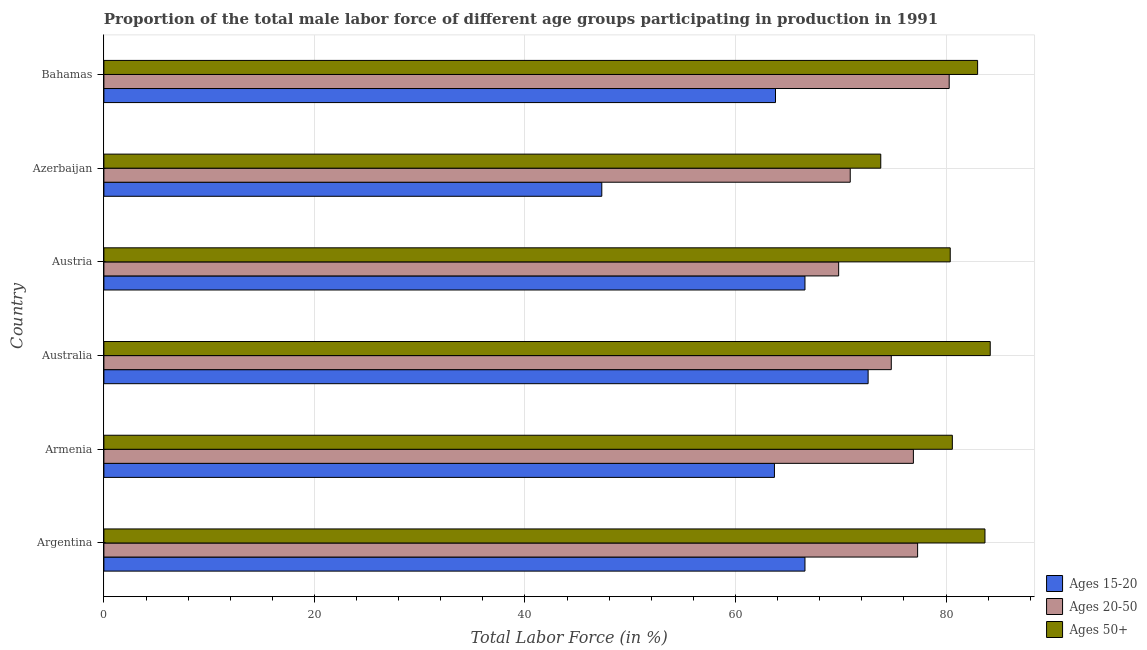Are the number of bars on each tick of the Y-axis equal?
Keep it short and to the point. Yes. What is the label of the 5th group of bars from the top?
Your answer should be very brief. Armenia. In how many cases, is the number of bars for a given country not equal to the number of legend labels?
Offer a very short reply. 0. What is the percentage of male labor force within the age group 20-50 in Armenia?
Ensure brevity in your answer.  76.9. Across all countries, what is the maximum percentage of male labor force within the age group 15-20?
Your answer should be very brief. 72.6. Across all countries, what is the minimum percentage of male labor force above age 50?
Make the answer very short. 73.8. In which country was the percentage of male labor force within the age group 15-20 minimum?
Your answer should be very brief. Azerbaijan. What is the total percentage of male labor force within the age group 20-50 in the graph?
Give a very brief answer. 450. What is the difference between the percentage of male labor force within the age group 15-20 in Austria and the percentage of male labor force above age 50 in Azerbaijan?
Offer a very short reply. -7.2. What is the average percentage of male labor force above age 50 per country?
Your answer should be compact. 80.95. What is the difference between the percentage of male labor force within the age group 15-20 and percentage of male labor force above age 50 in Argentina?
Ensure brevity in your answer.  -17.1. What is the ratio of the percentage of male labor force above age 50 in Australia to that in Austria?
Ensure brevity in your answer.  1.05. Is the difference between the percentage of male labor force above age 50 in Austria and Bahamas greater than the difference between the percentage of male labor force within the age group 15-20 in Austria and Bahamas?
Your response must be concise. No. What is the difference between the highest and the second highest percentage of male labor force above age 50?
Offer a very short reply. 0.5. What is the difference between the highest and the lowest percentage of male labor force within the age group 15-20?
Offer a very short reply. 25.3. Is the sum of the percentage of male labor force within the age group 15-20 in Austria and Azerbaijan greater than the maximum percentage of male labor force within the age group 20-50 across all countries?
Provide a succinct answer. Yes. What does the 3rd bar from the top in Azerbaijan represents?
Offer a very short reply. Ages 15-20. What does the 2nd bar from the bottom in Austria represents?
Offer a very short reply. Ages 20-50. Is it the case that in every country, the sum of the percentage of male labor force within the age group 15-20 and percentage of male labor force within the age group 20-50 is greater than the percentage of male labor force above age 50?
Make the answer very short. Yes. Are all the bars in the graph horizontal?
Your answer should be compact. Yes. Are the values on the major ticks of X-axis written in scientific E-notation?
Give a very brief answer. No. What is the title of the graph?
Provide a short and direct response. Proportion of the total male labor force of different age groups participating in production in 1991. What is the label or title of the X-axis?
Offer a very short reply. Total Labor Force (in %). What is the Total Labor Force (in %) in Ages 15-20 in Argentina?
Your response must be concise. 66.6. What is the Total Labor Force (in %) in Ages 20-50 in Argentina?
Your answer should be compact. 77.3. What is the Total Labor Force (in %) in Ages 50+ in Argentina?
Keep it short and to the point. 83.7. What is the Total Labor Force (in %) in Ages 15-20 in Armenia?
Give a very brief answer. 63.7. What is the Total Labor Force (in %) of Ages 20-50 in Armenia?
Offer a terse response. 76.9. What is the Total Labor Force (in %) of Ages 50+ in Armenia?
Provide a short and direct response. 80.6. What is the Total Labor Force (in %) in Ages 15-20 in Australia?
Ensure brevity in your answer.  72.6. What is the Total Labor Force (in %) of Ages 20-50 in Australia?
Offer a very short reply. 74.8. What is the Total Labor Force (in %) in Ages 50+ in Australia?
Give a very brief answer. 84.2. What is the Total Labor Force (in %) of Ages 15-20 in Austria?
Your answer should be compact. 66.6. What is the Total Labor Force (in %) of Ages 20-50 in Austria?
Your answer should be very brief. 69.8. What is the Total Labor Force (in %) in Ages 50+ in Austria?
Make the answer very short. 80.4. What is the Total Labor Force (in %) of Ages 15-20 in Azerbaijan?
Keep it short and to the point. 47.3. What is the Total Labor Force (in %) in Ages 20-50 in Azerbaijan?
Your response must be concise. 70.9. What is the Total Labor Force (in %) in Ages 50+ in Azerbaijan?
Give a very brief answer. 73.8. What is the Total Labor Force (in %) in Ages 15-20 in Bahamas?
Keep it short and to the point. 63.8. What is the Total Labor Force (in %) of Ages 20-50 in Bahamas?
Your response must be concise. 80.3. What is the Total Labor Force (in %) in Ages 50+ in Bahamas?
Make the answer very short. 83. Across all countries, what is the maximum Total Labor Force (in %) of Ages 15-20?
Your answer should be compact. 72.6. Across all countries, what is the maximum Total Labor Force (in %) of Ages 20-50?
Offer a terse response. 80.3. Across all countries, what is the maximum Total Labor Force (in %) of Ages 50+?
Offer a very short reply. 84.2. Across all countries, what is the minimum Total Labor Force (in %) in Ages 15-20?
Keep it short and to the point. 47.3. Across all countries, what is the minimum Total Labor Force (in %) of Ages 20-50?
Offer a terse response. 69.8. Across all countries, what is the minimum Total Labor Force (in %) in Ages 50+?
Offer a very short reply. 73.8. What is the total Total Labor Force (in %) of Ages 15-20 in the graph?
Your response must be concise. 380.6. What is the total Total Labor Force (in %) of Ages 20-50 in the graph?
Offer a very short reply. 450. What is the total Total Labor Force (in %) in Ages 50+ in the graph?
Make the answer very short. 485.7. What is the difference between the Total Labor Force (in %) in Ages 15-20 in Argentina and that in Armenia?
Keep it short and to the point. 2.9. What is the difference between the Total Labor Force (in %) in Ages 50+ in Argentina and that in Armenia?
Give a very brief answer. 3.1. What is the difference between the Total Labor Force (in %) of Ages 15-20 in Argentina and that in Australia?
Keep it short and to the point. -6. What is the difference between the Total Labor Force (in %) in Ages 20-50 in Argentina and that in Australia?
Ensure brevity in your answer.  2.5. What is the difference between the Total Labor Force (in %) of Ages 20-50 in Argentina and that in Austria?
Provide a short and direct response. 7.5. What is the difference between the Total Labor Force (in %) in Ages 50+ in Argentina and that in Austria?
Your answer should be very brief. 3.3. What is the difference between the Total Labor Force (in %) in Ages 15-20 in Argentina and that in Azerbaijan?
Ensure brevity in your answer.  19.3. What is the difference between the Total Labor Force (in %) in Ages 20-50 in Argentina and that in Azerbaijan?
Ensure brevity in your answer.  6.4. What is the difference between the Total Labor Force (in %) in Ages 50+ in Argentina and that in Azerbaijan?
Keep it short and to the point. 9.9. What is the difference between the Total Labor Force (in %) of Ages 15-20 in Argentina and that in Bahamas?
Offer a terse response. 2.8. What is the difference between the Total Labor Force (in %) in Ages 20-50 in Armenia and that in Austria?
Make the answer very short. 7.1. What is the difference between the Total Labor Force (in %) in Ages 50+ in Armenia and that in Austria?
Provide a short and direct response. 0.2. What is the difference between the Total Labor Force (in %) in Ages 15-20 in Armenia and that in Azerbaijan?
Offer a very short reply. 16.4. What is the difference between the Total Labor Force (in %) in Ages 20-50 in Armenia and that in Azerbaijan?
Your response must be concise. 6. What is the difference between the Total Labor Force (in %) of Ages 15-20 in Armenia and that in Bahamas?
Ensure brevity in your answer.  -0.1. What is the difference between the Total Labor Force (in %) of Ages 20-50 in Armenia and that in Bahamas?
Ensure brevity in your answer.  -3.4. What is the difference between the Total Labor Force (in %) of Ages 50+ in Australia and that in Austria?
Ensure brevity in your answer.  3.8. What is the difference between the Total Labor Force (in %) of Ages 15-20 in Australia and that in Azerbaijan?
Your answer should be compact. 25.3. What is the difference between the Total Labor Force (in %) in Ages 50+ in Australia and that in Azerbaijan?
Keep it short and to the point. 10.4. What is the difference between the Total Labor Force (in %) of Ages 50+ in Australia and that in Bahamas?
Provide a short and direct response. 1.2. What is the difference between the Total Labor Force (in %) of Ages 15-20 in Austria and that in Azerbaijan?
Provide a succinct answer. 19.3. What is the difference between the Total Labor Force (in %) of Ages 20-50 in Austria and that in Azerbaijan?
Your response must be concise. -1.1. What is the difference between the Total Labor Force (in %) of Ages 50+ in Austria and that in Azerbaijan?
Keep it short and to the point. 6.6. What is the difference between the Total Labor Force (in %) of Ages 20-50 in Austria and that in Bahamas?
Offer a terse response. -10.5. What is the difference between the Total Labor Force (in %) of Ages 50+ in Austria and that in Bahamas?
Offer a very short reply. -2.6. What is the difference between the Total Labor Force (in %) of Ages 15-20 in Azerbaijan and that in Bahamas?
Give a very brief answer. -16.5. What is the difference between the Total Labor Force (in %) in Ages 20-50 in Azerbaijan and that in Bahamas?
Ensure brevity in your answer.  -9.4. What is the difference between the Total Labor Force (in %) in Ages 15-20 in Argentina and the Total Labor Force (in %) in Ages 50+ in Armenia?
Your answer should be compact. -14. What is the difference between the Total Labor Force (in %) of Ages 15-20 in Argentina and the Total Labor Force (in %) of Ages 20-50 in Australia?
Your response must be concise. -8.2. What is the difference between the Total Labor Force (in %) in Ages 15-20 in Argentina and the Total Labor Force (in %) in Ages 50+ in Australia?
Offer a very short reply. -17.6. What is the difference between the Total Labor Force (in %) in Ages 15-20 in Argentina and the Total Labor Force (in %) in Ages 20-50 in Austria?
Give a very brief answer. -3.2. What is the difference between the Total Labor Force (in %) in Ages 15-20 in Argentina and the Total Labor Force (in %) in Ages 50+ in Austria?
Your answer should be very brief. -13.8. What is the difference between the Total Labor Force (in %) of Ages 15-20 in Argentina and the Total Labor Force (in %) of Ages 20-50 in Azerbaijan?
Ensure brevity in your answer.  -4.3. What is the difference between the Total Labor Force (in %) of Ages 15-20 in Argentina and the Total Labor Force (in %) of Ages 50+ in Azerbaijan?
Offer a very short reply. -7.2. What is the difference between the Total Labor Force (in %) of Ages 15-20 in Argentina and the Total Labor Force (in %) of Ages 20-50 in Bahamas?
Offer a terse response. -13.7. What is the difference between the Total Labor Force (in %) of Ages 15-20 in Argentina and the Total Labor Force (in %) of Ages 50+ in Bahamas?
Your answer should be compact. -16.4. What is the difference between the Total Labor Force (in %) of Ages 20-50 in Argentina and the Total Labor Force (in %) of Ages 50+ in Bahamas?
Give a very brief answer. -5.7. What is the difference between the Total Labor Force (in %) in Ages 15-20 in Armenia and the Total Labor Force (in %) in Ages 50+ in Australia?
Ensure brevity in your answer.  -20.5. What is the difference between the Total Labor Force (in %) in Ages 20-50 in Armenia and the Total Labor Force (in %) in Ages 50+ in Australia?
Keep it short and to the point. -7.3. What is the difference between the Total Labor Force (in %) of Ages 15-20 in Armenia and the Total Labor Force (in %) of Ages 50+ in Austria?
Your response must be concise. -16.7. What is the difference between the Total Labor Force (in %) of Ages 20-50 in Armenia and the Total Labor Force (in %) of Ages 50+ in Austria?
Ensure brevity in your answer.  -3.5. What is the difference between the Total Labor Force (in %) of Ages 20-50 in Armenia and the Total Labor Force (in %) of Ages 50+ in Azerbaijan?
Your answer should be compact. 3.1. What is the difference between the Total Labor Force (in %) of Ages 15-20 in Armenia and the Total Labor Force (in %) of Ages 20-50 in Bahamas?
Provide a short and direct response. -16.6. What is the difference between the Total Labor Force (in %) of Ages 15-20 in Armenia and the Total Labor Force (in %) of Ages 50+ in Bahamas?
Your response must be concise. -19.3. What is the difference between the Total Labor Force (in %) in Ages 15-20 in Australia and the Total Labor Force (in %) in Ages 20-50 in Austria?
Your response must be concise. 2.8. What is the difference between the Total Labor Force (in %) of Ages 15-20 in Australia and the Total Labor Force (in %) of Ages 50+ in Austria?
Your response must be concise. -7.8. What is the difference between the Total Labor Force (in %) in Ages 20-50 in Australia and the Total Labor Force (in %) in Ages 50+ in Austria?
Provide a short and direct response. -5.6. What is the difference between the Total Labor Force (in %) of Ages 20-50 in Australia and the Total Labor Force (in %) of Ages 50+ in Azerbaijan?
Provide a succinct answer. 1. What is the difference between the Total Labor Force (in %) in Ages 15-20 in Australia and the Total Labor Force (in %) in Ages 50+ in Bahamas?
Your response must be concise. -10.4. What is the difference between the Total Labor Force (in %) in Ages 20-50 in Australia and the Total Labor Force (in %) in Ages 50+ in Bahamas?
Offer a very short reply. -8.2. What is the difference between the Total Labor Force (in %) of Ages 15-20 in Austria and the Total Labor Force (in %) of Ages 50+ in Azerbaijan?
Give a very brief answer. -7.2. What is the difference between the Total Labor Force (in %) of Ages 15-20 in Austria and the Total Labor Force (in %) of Ages 20-50 in Bahamas?
Keep it short and to the point. -13.7. What is the difference between the Total Labor Force (in %) in Ages 15-20 in Austria and the Total Labor Force (in %) in Ages 50+ in Bahamas?
Your answer should be compact. -16.4. What is the difference between the Total Labor Force (in %) in Ages 20-50 in Austria and the Total Labor Force (in %) in Ages 50+ in Bahamas?
Make the answer very short. -13.2. What is the difference between the Total Labor Force (in %) in Ages 15-20 in Azerbaijan and the Total Labor Force (in %) in Ages 20-50 in Bahamas?
Make the answer very short. -33. What is the difference between the Total Labor Force (in %) of Ages 15-20 in Azerbaijan and the Total Labor Force (in %) of Ages 50+ in Bahamas?
Keep it short and to the point. -35.7. What is the average Total Labor Force (in %) in Ages 15-20 per country?
Make the answer very short. 63.43. What is the average Total Labor Force (in %) in Ages 20-50 per country?
Keep it short and to the point. 75. What is the average Total Labor Force (in %) in Ages 50+ per country?
Offer a very short reply. 80.95. What is the difference between the Total Labor Force (in %) in Ages 15-20 and Total Labor Force (in %) in Ages 20-50 in Argentina?
Make the answer very short. -10.7. What is the difference between the Total Labor Force (in %) of Ages 15-20 and Total Labor Force (in %) of Ages 50+ in Argentina?
Give a very brief answer. -17.1. What is the difference between the Total Labor Force (in %) of Ages 15-20 and Total Labor Force (in %) of Ages 50+ in Armenia?
Give a very brief answer. -16.9. What is the difference between the Total Labor Force (in %) in Ages 20-50 and Total Labor Force (in %) in Ages 50+ in Armenia?
Offer a very short reply. -3.7. What is the difference between the Total Labor Force (in %) in Ages 15-20 and Total Labor Force (in %) in Ages 20-50 in Australia?
Offer a very short reply. -2.2. What is the difference between the Total Labor Force (in %) in Ages 15-20 and Total Labor Force (in %) in Ages 50+ in Australia?
Offer a very short reply. -11.6. What is the difference between the Total Labor Force (in %) of Ages 20-50 and Total Labor Force (in %) of Ages 50+ in Australia?
Your response must be concise. -9.4. What is the difference between the Total Labor Force (in %) of Ages 15-20 and Total Labor Force (in %) of Ages 50+ in Austria?
Offer a very short reply. -13.8. What is the difference between the Total Labor Force (in %) of Ages 15-20 and Total Labor Force (in %) of Ages 20-50 in Azerbaijan?
Offer a very short reply. -23.6. What is the difference between the Total Labor Force (in %) of Ages 15-20 and Total Labor Force (in %) of Ages 50+ in Azerbaijan?
Make the answer very short. -26.5. What is the difference between the Total Labor Force (in %) of Ages 15-20 and Total Labor Force (in %) of Ages 20-50 in Bahamas?
Offer a terse response. -16.5. What is the difference between the Total Labor Force (in %) of Ages 15-20 and Total Labor Force (in %) of Ages 50+ in Bahamas?
Your response must be concise. -19.2. What is the difference between the Total Labor Force (in %) of Ages 20-50 and Total Labor Force (in %) of Ages 50+ in Bahamas?
Your response must be concise. -2.7. What is the ratio of the Total Labor Force (in %) in Ages 15-20 in Argentina to that in Armenia?
Your answer should be very brief. 1.05. What is the ratio of the Total Labor Force (in %) in Ages 20-50 in Argentina to that in Armenia?
Offer a very short reply. 1.01. What is the ratio of the Total Labor Force (in %) in Ages 15-20 in Argentina to that in Australia?
Make the answer very short. 0.92. What is the ratio of the Total Labor Force (in %) of Ages 20-50 in Argentina to that in Australia?
Your answer should be compact. 1.03. What is the ratio of the Total Labor Force (in %) of Ages 15-20 in Argentina to that in Austria?
Offer a terse response. 1. What is the ratio of the Total Labor Force (in %) of Ages 20-50 in Argentina to that in Austria?
Your answer should be very brief. 1.11. What is the ratio of the Total Labor Force (in %) of Ages 50+ in Argentina to that in Austria?
Ensure brevity in your answer.  1.04. What is the ratio of the Total Labor Force (in %) of Ages 15-20 in Argentina to that in Azerbaijan?
Offer a very short reply. 1.41. What is the ratio of the Total Labor Force (in %) of Ages 20-50 in Argentina to that in Azerbaijan?
Ensure brevity in your answer.  1.09. What is the ratio of the Total Labor Force (in %) in Ages 50+ in Argentina to that in Azerbaijan?
Provide a succinct answer. 1.13. What is the ratio of the Total Labor Force (in %) of Ages 15-20 in Argentina to that in Bahamas?
Your answer should be very brief. 1.04. What is the ratio of the Total Labor Force (in %) in Ages 20-50 in Argentina to that in Bahamas?
Offer a terse response. 0.96. What is the ratio of the Total Labor Force (in %) in Ages 50+ in Argentina to that in Bahamas?
Make the answer very short. 1.01. What is the ratio of the Total Labor Force (in %) of Ages 15-20 in Armenia to that in Australia?
Make the answer very short. 0.88. What is the ratio of the Total Labor Force (in %) of Ages 20-50 in Armenia to that in Australia?
Offer a terse response. 1.03. What is the ratio of the Total Labor Force (in %) in Ages 50+ in Armenia to that in Australia?
Give a very brief answer. 0.96. What is the ratio of the Total Labor Force (in %) of Ages 15-20 in Armenia to that in Austria?
Ensure brevity in your answer.  0.96. What is the ratio of the Total Labor Force (in %) in Ages 20-50 in Armenia to that in Austria?
Ensure brevity in your answer.  1.1. What is the ratio of the Total Labor Force (in %) in Ages 15-20 in Armenia to that in Azerbaijan?
Ensure brevity in your answer.  1.35. What is the ratio of the Total Labor Force (in %) in Ages 20-50 in Armenia to that in Azerbaijan?
Keep it short and to the point. 1.08. What is the ratio of the Total Labor Force (in %) in Ages 50+ in Armenia to that in Azerbaijan?
Offer a terse response. 1.09. What is the ratio of the Total Labor Force (in %) of Ages 20-50 in Armenia to that in Bahamas?
Ensure brevity in your answer.  0.96. What is the ratio of the Total Labor Force (in %) of Ages 50+ in Armenia to that in Bahamas?
Provide a short and direct response. 0.97. What is the ratio of the Total Labor Force (in %) in Ages 15-20 in Australia to that in Austria?
Keep it short and to the point. 1.09. What is the ratio of the Total Labor Force (in %) of Ages 20-50 in Australia to that in Austria?
Provide a short and direct response. 1.07. What is the ratio of the Total Labor Force (in %) in Ages 50+ in Australia to that in Austria?
Offer a terse response. 1.05. What is the ratio of the Total Labor Force (in %) of Ages 15-20 in Australia to that in Azerbaijan?
Ensure brevity in your answer.  1.53. What is the ratio of the Total Labor Force (in %) of Ages 20-50 in Australia to that in Azerbaijan?
Offer a terse response. 1.05. What is the ratio of the Total Labor Force (in %) of Ages 50+ in Australia to that in Azerbaijan?
Make the answer very short. 1.14. What is the ratio of the Total Labor Force (in %) of Ages 15-20 in Australia to that in Bahamas?
Provide a succinct answer. 1.14. What is the ratio of the Total Labor Force (in %) of Ages 20-50 in Australia to that in Bahamas?
Your response must be concise. 0.93. What is the ratio of the Total Labor Force (in %) of Ages 50+ in Australia to that in Bahamas?
Give a very brief answer. 1.01. What is the ratio of the Total Labor Force (in %) in Ages 15-20 in Austria to that in Azerbaijan?
Provide a succinct answer. 1.41. What is the ratio of the Total Labor Force (in %) in Ages 20-50 in Austria to that in Azerbaijan?
Make the answer very short. 0.98. What is the ratio of the Total Labor Force (in %) in Ages 50+ in Austria to that in Azerbaijan?
Offer a very short reply. 1.09. What is the ratio of the Total Labor Force (in %) of Ages 15-20 in Austria to that in Bahamas?
Your answer should be very brief. 1.04. What is the ratio of the Total Labor Force (in %) in Ages 20-50 in Austria to that in Bahamas?
Give a very brief answer. 0.87. What is the ratio of the Total Labor Force (in %) of Ages 50+ in Austria to that in Bahamas?
Your answer should be very brief. 0.97. What is the ratio of the Total Labor Force (in %) in Ages 15-20 in Azerbaijan to that in Bahamas?
Provide a succinct answer. 0.74. What is the ratio of the Total Labor Force (in %) of Ages 20-50 in Azerbaijan to that in Bahamas?
Ensure brevity in your answer.  0.88. What is the ratio of the Total Labor Force (in %) in Ages 50+ in Azerbaijan to that in Bahamas?
Give a very brief answer. 0.89. What is the difference between the highest and the second highest Total Labor Force (in %) of Ages 15-20?
Ensure brevity in your answer.  6. What is the difference between the highest and the second highest Total Labor Force (in %) of Ages 20-50?
Ensure brevity in your answer.  3. What is the difference between the highest and the lowest Total Labor Force (in %) in Ages 15-20?
Your answer should be very brief. 25.3. What is the difference between the highest and the lowest Total Labor Force (in %) of Ages 50+?
Your answer should be compact. 10.4. 